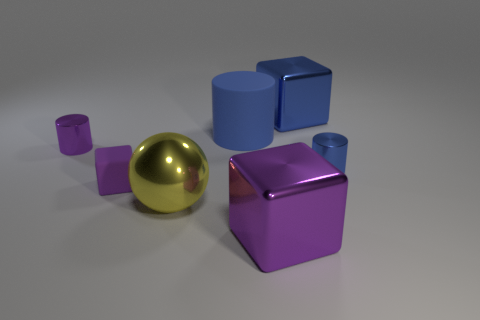Subtract all shiny cylinders. How many cylinders are left? 1 Add 3 rubber cubes. How many objects exist? 10 Subtract all purple cylinders. How many cylinders are left? 2 Subtract 1 balls. How many balls are left? 0 Subtract all purple spheres. How many purple blocks are left? 2 Add 4 shiny objects. How many shiny objects are left? 9 Add 1 large rubber cylinders. How many large rubber cylinders exist? 2 Subtract 1 purple cubes. How many objects are left? 6 Subtract all cylinders. How many objects are left? 4 Subtract all purple cylinders. Subtract all cyan cubes. How many cylinders are left? 2 